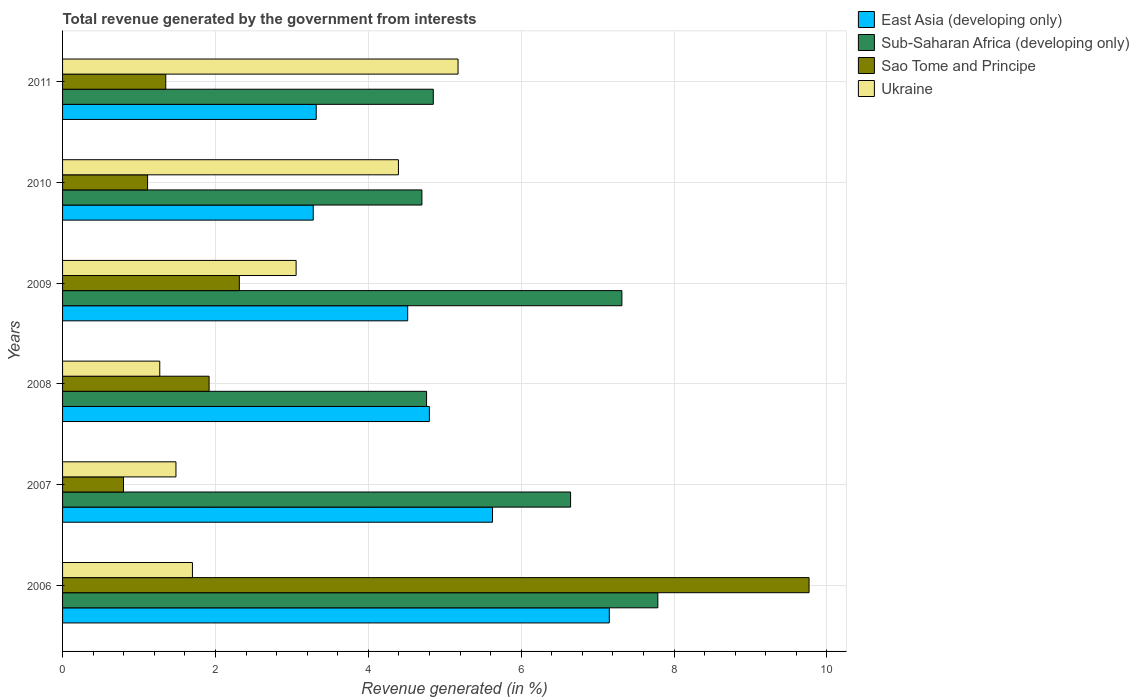How many groups of bars are there?
Provide a succinct answer. 6. Are the number of bars per tick equal to the number of legend labels?
Your answer should be compact. Yes. What is the total revenue generated in Sao Tome and Principe in 2006?
Offer a terse response. 9.77. Across all years, what is the maximum total revenue generated in Sub-Saharan Africa (developing only)?
Ensure brevity in your answer.  7.79. Across all years, what is the minimum total revenue generated in Sub-Saharan Africa (developing only)?
Ensure brevity in your answer.  4.7. What is the total total revenue generated in East Asia (developing only) in the graph?
Provide a short and direct response. 28.69. What is the difference between the total revenue generated in Sub-Saharan Africa (developing only) in 2007 and that in 2010?
Offer a very short reply. 1.95. What is the difference between the total revenue generated in Ukraine in 2009 and the total revenue generated in Sub-Saharan Africa (developing only) in 2007?
Provide a succinct answer. -3.59. What is the average total revenue generated in East Asia (developing only) per year?
Your answer should be compact. 4.78. In the year 2009, what is the difference between the total revenue generated in Ukraine and total revenue generated in East Asia (developing only)?
Offer a terse response. -1.46. What is the ratio of the total revenue generated in Sub-Saharan Africa (developing only) in 2006 to that in 2008?
Your answer should be compact. 1.64. Is the total revenue generated in East Asia (developing only) in 2008 less than that in 2009?
Offer a very short reply. No. Is the difference between the total revenue generated in Ukraine in 2007 and 2011 greater than the difference between the total revenue generated in East Asia (developing only) in 2007 and 2011?
Keep it short and to the point. No. What is the difference between the highest and the second highest total revenue generated in Sub-Saharan Africa (developing only)?
Your answer should be very brief. 0.47. What is the difference between the highest and the lowest total revenue generated in Sub-Saharan Africa (developing only)?
Offer a terse response. 3.09. Is it the case that in every year, the sum of the total revenue generated in Sub-Saharan Africa (developing only) and total revenue generated in East Asia (developing only) is greater than the sum of total revenue generated in Ukraine and total revenue generated in Sao Tome and Principe?
Ensure brevity in your answer.  No. What does the 2nd bar from the top in 2007 represents?
Keep it short and to the point. Sao Tome and Principe. What does the 2nd bar from the bottom in 2007 represents?
Your answer should be compact. Sub-Saharan Africa (developing only). How many bars are there?
Your answer should be very brief. 24. What is the difference between two consecutive major ticks on the X-axis?
Provide a short and direct response. 2. Are the values on the major ticks of X-axis written in scientific E-notation?
Offer a terse response. No. Does the graph contain grids?
Offer a very short reply. Yes. Where does the legend appear in the graph?
Ensure brevity in your answer.  Top right. What is the title of the graph?
Give a very brief answer. Total revenue generated by the government from interests. Does "Zambia" appear as one of the legend labels in the graph?
Offer a terse response. No. What is the label or title of the X-axis?
Your response must be concise. Revenue generated (in %). What is the Revenue generated (in %) in East Asia (developing only) in 2006?
Your response must be concise. 7.15. What is the Revenue generated (in %) in Sub-Saharan Africa (developing only) in 2006?
Make the answer very short. 7.79. What is the Revenue generated (in %) in Sao Tome and Principe in 2006?
Provide a succinct answer. 9.77. What is the Revenue generated (in %) of Ukraine in 2006?
Give a very brief answer. 1.7. What is the Revenue generated (in %) in East Asia (developing only) in 2007?
Give a very brief answer. 5.63. What is the Revenue generated (in %) in Sub-Saharan Africa (developing only) in 2007?
Ensure brevity in your answer.  6.65. What is the Revenue generated (in %) in Sao Tome and Principe in 2007?
Give a very brief answer. 0.8. What is the Revenue generated (in %) in Ukraine in 2007?
Offer a terse response. 1.48. What is the Revenue generated (in %) in East Asia (developing only) in 2008?
Your answer should be very brief. 4.8. What is the Revenue generated (in %) of Sub-Saharan Africa (developing only) in 2008?
Offer a terse response. 4.76. What is the Revenue generated (in %) in Sao Tome and Principe in 2008?
Keep it short and to the point. 1.92. What is the Revenue generated (in %) of Ukraine in 2008?
Ensure brevity in your answer.  1.27. What is the Revenue generated (in %) in East Asia (developing only) in 2009?
Give a very brief answer. 4.52. What is the Revenue generated (in %) of Sub-Saharan Africa (developing only) in 2009?
Offer a very short reply. 7.32. What is the Revenue generated (in %) in Sao Tome and Principe in 2009?
Your answer should be compact. 2.31. What is the Revenue generated (in %) in Ukraine in 2009?
Make the answer very short. 3.06. What is the Revenue generated (in %) of East Asia (developing only) in 2010?
Offer a terse response. 3.28. What is the Revenue generated (in %) of Sub-Saharan Africa (developing only) in 2010?
Provide a short and direct response. 4.7. What is the Revenue generated (in %) of Sao Tome and Principe in 2010?
Provide a short and direct response. 1.11. What is the Revenue generated (in %) of Ukraine in 2010?
Offer a terse response. 4.39. What is the Revenue generated (in %) in East Asia (developing only) in 2011?
Ensure brevity in your answer.  3.32. What is the Revenue generated (in %) of Sub-Saharan Africa (developing only) in 2011?
Your answer should be compact. 4.85. What is the Revenue generated (in %) of Sao Tome and Principe in 2011?
Your answer should be compact. 1.35. What is the Revenue generated (in %) in Ukraine in 2011?
Offer a very short reply. 5.17. Across all years, what is the maximum Revenue generated (in %) in East Asia (developing only)?
Provide a short and direct response. 7.15. Across all years, what is the maximum Revenue generated (in %) of Sub-Saharan Africa (developing only)?
Your answer should be compact. 7.79. Across all years, what is the maximum Revenue generated (in %) in Sao Tome and Principe?
Make the answer very short. 9.77. Across all years, what is the maximum Revenue generated (in %) in Ukraine?
Your answer should be compact. 5.17. Across all years, what is the minimum Revenue generated (in %) in East Asia (developing only)?
Provide a succinct answer. 3.28. Across all years, what is the minimum Revenue generated (in %) of Sub-Saharan Africa (developing only)?
Provide a short and direct response. 4.7. Across all years, what is the minimum Revenue generated (in %) of Sao Tome and Principe?
Ensure brevity in your answer.  0.8. Across all years, what is the minimum Revenue generated (in %) in Ukraine?
Offer a very short reply. 1.27. What is the total Revenue generated (in %) in East Asia (developing only) in the graph?
Ensure brevity in your answer.  28.69. What is the total Revenue generated (in %) of Sub-Saharan Africa (developing only) in the graph?
Provide a short and direct response. 36.07. What is the total Revenue generated (in %) in Sao Tome and Principe in the graph?
Offer a terse response. 17.26. What is the total Revenue generated (in %) of Ukraine in the graph?
Keep it short and to the point. 17.08. What is the difference between the Revenue generated (in %) in East Asia (developing only) in 2006 and that in 2007?
Offer a very short reply. 1.53. What is the difference between the Revenue generated (in %) in Sub-Saharan Africa (developing only) in 2006 and that in 2007?
Your response must be concise. 1.14. What is the difference between the Revenue generated (in %) in Sao Tome and Principe in 2006 and that in 2007?
Provide a short and direct response. 8.97. What is the difference between the Revenue generated (in %) of Ukraine in 2006 and that in 2007?
Your answer should be very brief. 0.22. What is the difference between the Revenue generated (in %) in East Asia (developing only) in 2006 and that in 2008?
Ensure brevity in your answer.  2.35. What is the difference between the Revenue generated (in %) in Sub-Saharan Africa (developing only) in 2006 and that in 2008?
Give a very brief answer. 3.03. What is the difference between the Revenue generated (in %) of Sao Tome and Principe in 2006 and that in 2008?
Keep it short and to the point. 7.85. What is the difference between the Revenue generated (in %) of Ukraine in 2006 and that in 2008?
Your answer should be very brief. 0.43. What is the difference between the Revenue generated (in %) of East Asia (developing only) in 2006 and that in 2009?
Your answer should be very brief. 2.64. What is the difference between the Revenue generated (in %) in Sub-Saharan Africa (developing only) in 2006 and that in 2009?
Your answer should be compact. 0.47. What is the difference between the Revenue generated (in %) in Sao Tome and Principe in 2006 and that in 2009?
Your response must be concise. 7.45. What is the difference between the Revenue generated (in %) of Ukraine in 2006 and that in 2009?
Give a very brief answer. -1.36. What is the difference between the Revenue generated (in %) of East Asia (developing only) in 2006 and that in 2010?
Your answer should be very brief. 3.87. What is the difference between the Revenue generated (in %) in Sub-Saharan Africa (developing only) in 2006 and that in 2010?
Your answer should be very brief. 3.09. What is the difference between the Revenue generated (in %) in Sao Tome and Principe in 2006 and that in 2010?
Provide a short and direct response. 8.65. What is the difference between the Revenue generated (in %) in Ukraine in 2006 and that in 2010?
Keep it short and to the point. -2.7. What is the difference between the Revenue generated (in %) of East Asia (developing only) in 2006 and that in 2011?
Provide a short and direct response. 3.83. What is the difference between the Revenue generated (in %) of Sub-Saharan Africa (developing only) in 2006 and that in 2011?
Give a very brief answer. 2.94. What is the difference between the Revenue generated (in %) in Sao Tome and Principe in 2006 and that in 2011?
Ensure brevity in your answer.  8.42. What is the difference between the Revenue generated (in %) of Ukraine in 2006 and that in 2011?
Make the answer very short. -3.48. What is the difference between the Revenue generated (in %) in East Asia (developing only) in 2007 and that in 2008?
Give a very brief answer. 0.83. What is the difference between the Revenue generated (in %) in Sub-Saharan Africa (developing only) in 2007 and that in 2008?
Ensure brevity in your answer.  1.88. What is the difference between the Revenue generated (in %) in Sao Tome and Principe in 2007 and that in 2008?
Keep it short and to the point. -1.12. What is the difference between the Revenue generated (in %) of Ukraine in 2007 and that in 2008?
Your response must be concise. 0.21. What is the difference between the Revenue generated (in %) of East Asia (developing only) in 2007 and that in 2009?
Give a very brief answer. 1.11. What is the difference between the Revenue generated (in %) of Sub-Saharan Africa (developing only) in 2007 and that in 2009?
Keep it short and to the point. -0.67. What is the difference between the Revenue generated (in %) of Sao Tome and Principe in 2007 and that in 2009?
Provide a succinct answer. -1.52. What is the difference between the Revenue generated (in %) in Ukraine in 2007 and that in 2009?
Your answer should be compact. -1.57. What is the difference between the Revenue generated (in %) of East Asia (developing only) in 2007 and that in 2010?
Make the answer very short. 2.35. What is the difference between the Revenue generated (in %) in Sub-Saharan Africa (developing only) in 2007 and that in 2010?
Offer a terse response. 1.95. What is the difference between the Revenue generated (in %) in Sao Tome and Principe in 2007 and that in 2010?
Offer a very short reply. -0.31. What is the difference between the Revenue generated (in %) of Ukraine in 2007 and that in 2010?
Give a very brief answer. -2.91. What is the difference between the Revenue generated (in %) of East Asia (developing only) in 2007 and that in 2011?
Give a very brief answer. 2.31. What is the difference between the Revenue generated (in %) of Sub-Saharan Africa (developing only) in 2007 and that in 2011?
Keep it short and to the point. 1.8. What is the difference between the Revenue generated (in %) of Sao Tome and Principe in 2007 and that in 2011?
Offer a very short reply. -0.55. What is the difference between the Revenue generated (in %) in Ukraine in 2007 and that in 2011?
Keep it short and to the point. -3.69. What is the difference between the Revenue generated (in %) of East Asia (developing only) in 2008 and that in 2009?
Provide a short and direct response. 0.28. What is the difference between the Revenue generated (in %) of Sub-Saharan Africa (developing only) in 2008 and that in 2009?
Give a very brief answer. -2.56. What is the difference between the Revenue generated (in %) of Sao Tome and Principe in 2008 and that in 2009?
Make the answer very short. -0.4. What is the difference between the Revenue generated (in %) of Ukraine in 2008 and that in 2009?
Your answer should be compact. -1.78. What is the difference between the Revenue generated (in %) in East Asia (developing only) in 2008 and that in 2010?
Ensure brevity in your answer.  1.52. What is the difference between the Revenue generated (in %) in Sub-Saharan Africa (developing only) in 2008 and that in 2010?
Make the answer very short. 0.06. What is the difference between the Revenue generated (in %) of Sao Tome and Principe in 2008 and that in 2010?
Your answer should be compact. 0.8. What is the difference between the Revenue generated (in %) in Ukraine in 2008 and that in 2010?
Your response must be concise. -3.12. What is the difference between the Revenue generated (in %) of East Asia (developing only) in 2008 and that in 2011?
Your answer should be very brief. 1.48. What is the difference between the Revenue generated (in %) of Sub-Saharan Africa (developing only) in 2008 and that in 2011?
Offer a very short reply. -0.09. What is the difference between the Revenue generated (in %) in Sao Tome and Principe in 2008 and that in 2011?
Ensure brevity in your answer.  0.57. What is the difference between the Revenue generated (in %) in Ukraine in 2008 and that in 2011?
Your response must be concise. -3.9. What is the difference between the Revenue generated (in %) of East Asia (developing only) in 2009 and that in 2010?
Provide a succinct answer. 1.24. What is the difference between the Revenue generated (in %) of Sub-Saharan Africa (developing only) in 2009 and that in 2010?
Offer a terse response. 2.62. What is the difference between the Revenue generated (in %) of Sao Tome and Principe in 2009 and that in 2010?
Provide a succinct answer. 1.2. What is the difference between the Revenue generated (in %) in Ukraine in 2009 and that in 2010?
Your response must be concise. -1.34. What is the difference between the Revenue generated (in %) of East Asia (developing only) in 2009 and that in 2011?
Offer a terse response. 1.2. What is the difference between the Revenue generated (in %) of Sub-Saharan Africa (developing only) in 2009 and that in 2011?
Ensure brevity in your answer.  2.47. What is the difference between the Revenue generated (in %) of Sao Tome and Principe in 2009 and that in 2011?
Give a very brief answer. 0.96. What is the difference between the Revenue generated (in %) of Ukraine in 2009 and that in 2011?
Offer a very short reply. -2.12. What is the difference between the Revenue generated (in %) in East Asia (developing only) in 2010 and that in 2011?
Give a very brief answer. -0.04. What is the difference between the Revenue generated (in %) in Sub-Saharan Africa (developing only) in 2010 and that in 2011?
Keep it short and to the point. -0.15. What is the difference between the Revenue generated (in %) in Sao Tome and Principe in 2010 and that in 2011?
Keep it short and to the point. -0.24. What is the difference between the Revenue generated (in %) of Ukraine in 2010 and that in 2011?
Ensure brevity in your answer.  -0.78. What is the difference between the Revenue generated (in %) in East Asia (developing only) in 2006 and the Revenue generated (in %) in Sub-Saharan Africa (developing only) in 2007?
Keep it short and to the point. 0.51. What is the difference between the Revenue generated (in %) of East Asia (developing only) in 2006 and the Revenue generated (in %) of Sao Tome and Principe in 2007?
Offer a terse response. 6.36. What is the difference between the Revenue generated (in %) of East Asia (developing only) in 2006 and the Revenue generated (in %) of Ukraine in 2007?
Your answer should be very brief. 5.67. What is the difference between the Revenue generated (in %) in Sub-Saharan Africa (developing only) in 2006 and the Revenue generated (in %) in Sao Tome and Principe in 2007?
Give a very brief answer. 6.99. What is the difference between the Revenue generated (in %) of Sub-Saharan Africa (developing only) in 2006 and the Revenue generated (in %) of Ukraine in 2007?
Make the answer very short. 6.3. What is the difference between the Revenue generated (in %) in Sao Tome and Principe in 2006 and the Revenue generated (in %) in Ukraine in 2007?
Ensure brevity in your answer.  8.28. What is the difference between the Revenue generated (in %) of East Asia (developing only) in 2006 and the Revenue generated (in %) of Sub-Saharan Africa (developing only) in 2008?
Ensure brevity in your answer.  2.39. What is the difference between the Revenue generated (in %) in East Asia (developing only) in 2006 and the Revenue generated (in %) in Sao Tome and Principe in 2008?
Provide a short and direct response. 5.24. What is the difference between the Revenue generated (in %) of East Asia (developing only) in 2006 and the Revenue generated (in %) of Ukraine in 2008?
Your answer should be very brief. 5.88. What is the difference between the Revenue generated (in %) of Sub-Saharan Africa (developing only) in 2006 and the Revenue generated (in %) of Sao Tome and Principe in 2008?
Your answer should be very brief. 5.87. What is the difference between the Revenue generated (in %) in Sub-Saharan Africa (developing only) in 2006 and the Revenue generated (in %) in Ukraine in 2008?
Make the answer very short. 6.52. What is the difference between the Revenue generated (in %) in Sao Tome and Principe in 2006 and the Revenue generated (in %) in Ukraine in 2008?
Your answer should be compact. 8.5. What is the difference between the Revenue generated (in %) of East Asia (developing only) in 2006 and the Revenue generated (in %) of Sub-Saharan Africa (developing only) in 2009?
Your response must be concise. -0.16. What is the difference between the Revenue generated (in %) of East Asia (developing only) in 2006 and the Revenue generated (in %) of Sao Tome and Principe in 2009?
Give a very brief answer. 4.84. What is the difference between the Revenue generated (in %) of East Asia (developing only) in 2006 and the Revenue generated (in %) of Ukraine in 2009?
Make the answer very short. 4.1. What is the difference between the Revenue generated (in %) of Sub-Saharan Africa (developing only) in 2006 and the Revenue generated (in %) of Sao Tome and Principe in 2009?
Give a very brief answer. 5.48. What is the difference between the Revenue generated (in %) in Sub-Saharan Africa (developing only) in 2006 and the Revenue generated (in %) in Ukraine in 2009?
Give a very brief answer. 4.73. What is the difference between the Revenue generated (in %) of Sao Tome and Principe in 2006 and the Revenue generated (in %) of Ukraine in 2009?
Offer a terse response. 6.71. What is the difference between the Revenue generated (in %) in East Asia (developing only) in 2006 and the Revenue generated (in %) in Sub-Saharan Africa (developing only) in 2010?
Offer a terse response. 2.45. What is the difference between the Revenue generated (in %) in East Asia (developing only) in 2006 and the Revenue generated (in %) in Sao Tome and Principe in 2010?
Your answer should be compact. 6.04. What is the difference between the Revenue generated (in %) of East Asia (developing only) in 2006 and the Revenue generated (in %) of Ukraine in 2010?
Your response must be concise. 2.76. What is the difference between the Revenue generated (in %) of Sub-Saharan Africa (developing only) in 2006 and the Revenue generated (in %) of Sao Tome and Principe in 2010?
Provide a short and direct response. 6.68. What is the difference between the Revenue generated (in %) in Sub-Saharan Africa (developing only) in 2006 and the Revenue generated (in %) in Ukraine in 2010?
Provide a succinct answer. 3.39. What is the difference between the Revenue generated (in %) of Sao Tome and Principe in 2006 and the Revenue generated (in %) of Ukraine in 2010?
Keep it short and to the point. 5.37. What is the difference between the Revenue generated (in %) in East Asia (developing only) in 2006 and the Revenue generated (in %) in Sub-Saharan Africa (developing only) in 2011?
Keep it short and to the point. 2.3. What is the difference between the Revenue generated (in %) of East Asia (developing only) in 2006 and the Revenue generated (in %) of Sao Tome and Principe in 2011?
Provide a short and direct response. 5.8. What is the difference between the Revenue generated (in %) of East Asia (developing only) in 2006 and the Revenue generated (in %) of Ukraine in 2011?
Offer a terse response. 1.98. What is the difference between the Revenue generated (in %) of Sub-Saharan Africa (developing only) in 2006 and the Revenue generated (in %) of Sao Tome and Principe in 2011?
Your answer should be compact. 6.44. What is the difference between the Revenue generated (in %) of Sub-Saharan Africa (developing only) in 2006 and the Revenue generated (in %) of Ukraine in 2011?
Offer a terse response. 2.61. What is the difference between the Revenue generated (in %) in Sao Tome and Principe in 2006 and the Revenue generated (in %) in Ukraine in 2011?
Your answer should be very brief. 4.59. What is the difference between the Revenue generated (in %) in East Asia (developing only) in 2007 and the Revenue generated (in %) in Sub-Saharan Africa (developing only) in 2008?
Your answer should be very brief. 0.86. What is the difference between the Revenue generated (in %) of East Asia (developing only) in 2007 and the Revenue generated (in %) of Sao Tome and Principe in 2008?
Offer a very short reply. 3.71. What is the difference between the Revenue generated (in %) in East Asia (developing only) in 2007 and the Revenue generated (in %) in Ukraine in 2008?
Make the answer very short. 4.35. What is the difference between the Revenue generated (in %) in Sub-Saharan Africa (developing only) in 2007 and the Revenue generated (in %) in Sao Tome and Principe in 2008?
Your answer should be very brief. 4.73. What is the difference between the Revenue generated (in %) in Sub-Saharan Africa (developing only) in 2007 and the Revenue generated (in %) in Ukraine in 2008?
Your answer should be very brief. 5.37. What is the difference between the Revenue generated (in %) in Sao Tome and Principe in 2007 and the Revenue generated (in %) in Ukraine in 2008?
Your answer should be compact. -0.47. What is the difference between the Revenue generated (in %) of East Asia (developing only) in 2007 and the Revenue generated (in %) of Sub-Saharan Africa (developing only) in 2009?
Your answer should be compact. -1.69. What is the difference between the Revenue generated (in %) of East Asia (developing only) in 2007 and the Revenue generated (in %) of Sao Tome and Principe in 2009?
Your answer should be very brief. 3.31. What is the difference between the Revenue generated (in %) in East Asia (developing only) in 2007 and the Revenue generated (in %) in Ukraine in 2009?
Provide a succinct answer. 2.57. What is the difference between the Revenue generated (in %) of Sub-Saharan Africa (developing only) in 2007 and the Revenue generated (in %) of Sao Tome and Principe in 2009?
Your answer should be very brief. 4.33. What is the difference between the Revenue generated (in %) of Sub-Saharan Africa (developing only) in 2007 and the Revenue generated (in %) of Ukraine in 2009?
Keep it short and to the point. 3.59. What is the difference between the Revenue generated (in %) in Sao Tome and Principe in 2007 and the Revenue generated (in %) in Ukraine in 2009?
Provide a succinct answer. -2.26. What is the difference between the Revenue generated (in %) of East Asia (developing only) in 2007 and the Revenue generated (in %) of Sub-Saharan Africa (developing only) in 2010?
Provide a succinct answer. 0.92. What is the difference between the Revenue generated (in %) in East Asia (developing only) in 2007 and the Revenue generated (in %) in Sao Tome and Principe in 2010?
Provide a succinct answer. 4.51. What is the difference between the Revenue generated (in %) of East Asia (developing only) in 2007 and the Revenue generated (in %) of Ukraine in 2010?
Offer a very short reply. 1.23. What is the difference between the Revenue generated (in %) in Sub-Saharan Africa (developing only) in 2007 and the Revenue generated (in %) in Sao Tome and Principe in 2010?
Your answer should be compact. 5.53. What is the difference between the Revenue generated (in %) of Sub-Saharan Africa (developing only) in 2007 and the Revenue generated (in %) of Ukraine in 2010?
Provide a short and direct response. 2.25. What is the difference between the Revenue generated (in %) in Sao Tome and Principe in 2007 and the Revenue generated (in %) in Ukraine in 2010?
Keep it short and to the point. -3.6. What is the difference between the Revenue generated (in %) in East Asia (developing only) in 2007 and the Revenue generated (in %) in Sub-Saharan Africa (developing only) in 2011?
Ensure brevity in your answer.  0.77. What is the difference between the Revenue generated (in %) in East Asia (developing only) in 2007 and the Revenue generated (in %) in Sao Tome and Principe in 2011?
Keep it short and to the point. 4.28. What is the difference between the Revenue generated (in %) of East Asia (developing only) in 2007 and the Revenue generated (in %) of Ukraine in 2011?
Offer a terse response. 0.45. What is the difference between the Revenue generated (in %) of Sub-Saharan Africa (developing only) in 2007 and the Revenue generated (in %) of Sao Tome and Principe in 2011?
Make the answer very short. 5.3. What is the difference between the Revenue generated (in %) in Sub-Saharan Africa (developing only) in 2007 and the Revenue generated (in %) in Ukraine in 2011?
Your answer should be very brief. 1.47. What is the difference between the Revenue generated (in %) in Sao Tome and Principe in 2007 and the Revenue generated (in %) in Ukraine in 2011?
Keep it short and to the point. -4.38. What is the difference between the Revenue generated (in %) in East Asia (developing only) in 2008 and the Revenue generated (in %) in Sub-Saharan Africa (developing only) in 2009?
Your answer should be compact. -2.52. What is the difference between the Revenue generated (in %) of East Asia (developing only) in 2008 and the Revenue generated (in %) of Sao Tome and Principe in 2009?
Keep it short and to the point. 2.49. What is the difference between the Revenue generated (in %) in East Asia (developing only) in 2008 and the Revenue generated (in %) in Ukraine in 2009?
Make the answer very short. 1.74. What is the difference between the Revenue generated (in %) in Sub-Saharan Africa (developing only) in 2008 and the Revenue generated (in %) in Sao Tome and Principe in 2009?
Give a very brief answer. 2.45. What is the difference between the Revenue generated (in %) of Sub-Saharan Africa (developing only) in 2008 and the Revenue generated (in %) of Ukraine in 2009?
Keep it short and to the point. 1.71. What is the difference between the Revenue generated (in %) in Sao Tome and Principe in 2008 and the Revenue generated (in %) in Ukraine in 2009?
Your answer should be very brief. -1.14. What is the difference between the Revenue generated (in %) in East Asia (developing only) in 2008 and the Revenue generated (in %) in Sub-Saharan Africa (developing only) in 2010?
Make the answer very short. 0.1. What is the difference between the Revenue generated (in %) of East Asia (developing only) in 2008 and the Revenue generated (in %) of Sao Tome and Principe in 2010?
Your response must be concise. 3.69. What is the difference between the Revenue generated (in %) of East Asia (developing only) in 2008 and the Revenue generated (in %) of Ukraine in 2010?
Give a very brief answer. 0.4. What is the difference between the Revenue generated (in %) in Sub-Saharan Africa (developing only) in 2008 and the Revenue generated (in %) in Sao Tome and Principe in 2010?
Your answer should be very brief. 3.65. What is the difference between the Revenue generated (in %) of Sub-Saharan Africa (developing only) in 2008 and the Revenue generated (in %) of Ukraine in 2010?
Give a very brief answer. 0.37. What is the difference between the Revenue generated (in %) of Sao Tome and Principe in 2008 and the Revenue generated (in %) of Ukraine in 2010?
Ensure brevity in your answer.  -2.48. What is the difference between the Revenue generated (in %) of East Asia (developing only) in 2008 and the Revenue generated (in %) of Sub-Saharan Africa (developing only) in 2011?
Make the answer very short. -0.05. What is the difference between the Revenue generated (in %) in East Asia (developing only) in 2008 and the Revenue generated (in %) in Sao Tome and Principe in 2011?
Offer a very short reply. 3.45. What is the difference between the Revenue generated (in %) of East Asia (developing only) in 2008 and the Revenue generated (in %) of Ukraine in 2011?
Your response must be concise. -0.38. What is the difference between the Revenue generated (in %) of Sub-Saharan Africa (developing only) in 2008 and the Revenue generated (in %) of Sao Tome and Principe in 2011?
Provide a succinct answer. 3.41. What is the difference between the Revenue generated (in %) in Sub-Saharan Africa (developing only) in 2008 and the Revenue generated (in %) in Ukraine in 2011?
Offer a very short reply. -0.41. What is the difference between the Revenue generated (in %) in Sao Tome and Principe in 2008 and the Revenue generated (in %) in Ukraine in 2011?
Your answer should be compact. -3.26. What is the difference between the Revenue generated (in %) in East Asia (developing only) in 2009 and the Revenue generated (in %) in Sub-Saharan Africa (developing only) in 2010?
Ensure brevity in your answer.  -0.19. What is the difference between the Revenue generated (in %) in East Asia (developing only) in 2009 and the Revenue generated (in %) in Sao Tome and Principe in 2010?
Offer a terse response. 3.4. What is the difference between the Revenue generated (in %) of East Asia (developing only) in 2009 and the Revenue generated (in %) of Ukraine in 2010?
Provide a short and direct response. 0.12. What is the difference between the Revenue generated (in %) of Sub-Saharan Africa (developing only) in 2009 and the Revenue generated (in %) of Sao Tome and Principe in 2010?
Your answer should be compact. 6.21. What is the difference between the Revenue generated (in %) of Sub-Saharan Africa (developing only) in 2009 and the Revenue generated (in %) of Ukraine in 2010?
Offer a terse response. 2.92. What is the difference between the Revenue generated (in %) of Sao Tome and Principe in 2009 and the Revenue generated (in %) of Ukraine in 2010?
Offer a very short reply. -2.08. What is the difference between the Revenue generated (in %) of East Asia (developing only) in 2009 and the Revenue generated (in %) of Sub-Saharan Africa (developing only) in 2011?
Make the answer very short. -0.34. What is the difference between the Revenue generated (in %) in East Asia (developing only) in 2009 and the Revenue generated (in %) in Sao Tome and Principe in 2011?
Make the answer very short. 3.17. What is the difference between the Revenue generated (in %) of East Asia (developing only) in 2009 and the Revenue generated (in %) of Ukraine in 2011?
Offer a terse response. -0.66. What is the difference between the Revenue generated (in %) in Sub-Saharan Africa (developing only) in 2009 and the Revenue generated (in %) in Sao Tome and Principe in 2011?
Your answer should be very brief. 5.97. What is the difference between the Revenue generated (in %) in Sub-Saharan Africa (developing only) in 2009 and the Revenue generated (in %) in Ukraine in 2011?
Provide a short and direct response. 2.14. What is the difference between the Revenue generated (in %) of Sao Tome and Principe in 2009 and the Revenue generated (in %) of Ukraine in 2011?
Give a very brief answer. -2.86. What is the difference between the Revenue generated (in %) of East Asia (developing only) in 2010 and the Revenue generated (in %) of Sub-Saharan Africa (developing only) in 2011?
Keep it short and to the point. -1.57. What is the difference between the Revenue generated (in %) in East Asia (developing only) in 2010 and the Revenue generated (in %) in Sao Tome and Principe in 2011?
Keep it short and to the point. 1.93. What is the difference between the Revenue generated (in %) in East Asia (developing only) in 2010 and the Revenue generated (in %) in Ukraine in 2011?
Give a very brief answer. -1.89. What is the difference between the Revenue generated (in %) of Sub-Saharan Africa (developing only) in 2010 and the Revenue generated (in %) of Sao Tome and Principe in 2011?
Make the answer very short. 3.35. What is the difference between the Revenue generated (in %) of Sub-Saharan Africa (developing only) in 2010 and the Revenue generated (in %) of Ukraine in 2011?
Give a very brief answer. -0.47. What is the difference between the Revenue generated (in %) in Sao Tome and Principe in 2010 and the Revenue generated (in %) in Ukraine in 2011?
Your response must be concise. -4.06. What is the average Revenue generated (in %) of East Asia (developing only) per year?
Provide a short and direct response. 4.78. What is the average Revenue generated (in %) in Sub-Saharan Africa (developing only) per year?
Provide a succinct answer. 6.01. What is the average Revenue generated (in %) in Sao Tome and Principe per year?
Offer a terse response. 2.88. What is the average Revenue generated (in %) of Ukraine per year?
Ensure brevity in your answer.  2.85. In the year 2006, what is the difference between the Revenue generated (in %) in East Asia (developing only) and Revenue generated (in %) in Sub-Saharan Africa (developing only)?
Your response must be concise. -0.64. In the year 2006, what is the difference between the Revenue generated (in %) in East Asia (developing only) and Revenue generated (in %) in Sao Tome and Principe?
Your answer should be very brief. -2.61. In the year 2006, what is the difference between the Revenue generated (in %) in East Asia (developing only) and Revenue generated (in %) in Ukraine?
Offer a very short reply. 5.45. In the year 2006, what is the difference between the Revenue generated (in %) in Sub-Saharan Africa (developing only) and Revenue generated (in %) in Sao Tome and Principe?
Ensure brevity in your answer.  -1.98. In the year 2006, what is the difference between the Revenue generated (in %) of Sub-Saharan Africa (developing only) and Revenue generated (in %) of Ukraine?
Give a very brief answer. 6.09. In the year 2006, what is the difference between the Revenue generated (in %) in Sao Tome and Principe and Revenue generated (in %) in Ukraine?
Provide a succinct answer. 8.07. In the year 2007, what is the difference between the Revenue generated (in %) of East Asia (developing only) and Revenue generated (in %) of Sub-Saharan Africa (developing only)?
Provide a short and direct response. -1.02. In the year 2007, what is the difference between the Revenue generated (in %) in East Asia (developing only) and Revenue generated (in %) in Sao Tome and Principe?
Provide a succinct answer. 4.83. In the year 2007, what is the difference between the Revenue generated (in %) in East Asia (developing only) and Revenue generated (in %) in Ukraine?
Ensure brevity in your answer.  4.14. In the year 2007, what is the difference between the Revenue generated (in %) in Sub-Saharan Africa (developing only) and Revenue generated (in %) in Sao Tome and Principe?
Give a very brief answer. 5.85. In the year 2007, what is the difference between the Revenue generated (in %) in Sub-Saharan Africa (developing only) and Revenue generated (in %) in Ukraine?
Make the answer very short. 5.16. In the year 2007, what is the difference between the Revenue generated (in %) in Sao Tome and Principe and Revenue generated (in %) in Ukraine?
Offer a very short reply. -0.69. In the year 2008, what is the difference between the Revenue generated (in %) in East Asia (developing only) and Revenue generated (in %) in Sub-Saharan Africa (developing only)?
Offer a very short reply. 0.04. In the year 2008, what is the difference between the Revenue generated (in %) of East Asia (developing only) and Revenue generated (in %) of Sao Tome and Principe?
Ensure brevity in your answer.  2.88. In the year 2008, what is the difference between the Revenue generated (in %) in East Asia (developing only) and Revenue generated (in %) in Ukraine?
Your answer should be compact. 3.53. In the year 2008, what is the difference between the Revenue generated (in %) of Sub-Saharan Africa (developing only) and Revenue generated (in %) of Sao Tome and Principe?
Provide a succinct answer. 2.85. In the year 2008, what is the difference between the Revenue generated (in %) of Sub-Saharan Africa (developing only) and Revenue generated (in %) of Ukraine?
Offer a terse response. 3.49. In the year 2008, what is the difference between the Revenue generated (in %) in Sao Tome and Principe and Revenue generated (in %) in Ukraine?
Your answer should be compact. 0.65. In the year 2009, what is the difference between the Revenue generated (in %) of East Asia (developing only) and Revenue generated (in %) of Sub-Saharan Africa (developing only)?
Offer a terse response. -2.8. In the year 2009, what is the difference between the Revenue generated (in %) in East Asia (developing only) and Revenue generated (in %) in Sao Tome and Principe?
Offer a very short reply. 2.2. In the year 2009, what is the difference between the Revenue generated (in %) of East Asia (developing only) and Revenue generated (in %) of Ukraine?
Your response must be concise. 1.46. In the year 2009, what is the difference between the Revenue generated (in %) in Sub-Saharan Africa (developing only) and Revenue generated (in %) in Sao Tome and Principe?
Your response must be concise. 5.01. In the year 2009, what is the difference between the Revenue generated (in %) of Sub-Saharan Africa (developing only) and Revenue generated (in %) of Ukraine?
Give a very brief answer. 4.26. In the year 2009, what is the difference between the Revenue generated (in %) in Sao Tome and Principe and Revenue generated (in %) in Ukraine?
Your answer should be very brief. -0.74. In the year 2010, what is the difference between the Revenue generated (in %) of East Asia (developing only) and Revenue generated (in %) of Sub-Saharan Africa (developing only)?
Keep it short and to the point. -1.42. In the year 2010, what is the difference between the Revenue generated (in %) of East Asia (developing only) and Revenue generated (in %) of Sao Tome and Principe?
Ensure brevity in your answer.  2.17. In the year 2010, what is the difference between the Revenue generated (in %) of East Asia (developing only) and Revenue generated (in %) of Ukraine?
Offer a terse response. -1.11. In the year 2010, what is the difference between the Revenue generated (in %) in Sub-Saharan Africa (developing only) and Revenue generated (in %) in Sao Tome and Principe?
Offer a terse response. 3.59. In the year 2010, what is the difference between the Revenue generated (in %) of Sub-Saharan Africa (developing only) and Revenue generated (in %) of Ukraine?
Provide a short and direct response. 0.31. In the year 2010, what is the difference between the Revenue generated (in %) in Sao Tome and Principe and Revenue generated (in %) in Ukraine?
Make the answer very short. -3.28. In the year 2011, what is the difference between the Revenue generated (in %) in East Asia (developing only) and Revenue generated (in %) in Sub-Saharan Africa (developing only)?
Your answer should be compact. -1.53. In the year 2011, what is the difference between the Revenue generated (in %) in East Asia (developing only) and Revenue generated (in %) in Sao Tome and Principe?
Give a very brief answer. 1.97. In the year 2011, what is the difference between the Revenue generated (in %) of East Asia (developing only) and Revenue generated (in %) of Ukraine?
Offer a very short reply. -1.86. In the year 2011, what is the difference between the Revenue generated (in %) in Sub-Saharan Africa (developing only) and Revenue generated (in %) in Sao Tome and Principe?
Your answer should be compact. 3.5. In the year 2011, what is the difference between the Revenue generated (in %) in Sub-Saharan Africa (developing only) and Revenue generated (in %) in Ukraine?
Make the answer very short. -0.32. In the year 2011, what is the difference between the Revenue generated (in %) of Sao Tome and Principe and Revenue generated (in %) of Ukraine?
Give a very brief answer. -3.82. What is the ratio of the Revenue generated (in %) in East Asia (developing only) in 2006 to that in 2007?
Provide a succinct answer. 1.27. What is the ratio of the Revenue generated (in %) in Sub-Saharan Africa (developing only) in 2006 to that in 2007?
Provide a succinct answer. 1.17. What is the ratio of the Revenue generated (in %) in Sao Tome and Principe in 2006 to that in 2007?
Offer a terse response. 12.25. What is the ratio of the Revenue generated (in %) of Ukraine in 2006 to that in 2007?
Your answer should be very brief. 1.15. What is the ratio of the Revenue generated (in %) in East Asia (developing only) in 2006 to that in 2008?
Your answer should be compact. 1.49. What is the ratio of the Revenue generated (in %) of Sub-Saharan Africa (developing only) in 2006 to that in 2008?
Provide a succinct answer. 1.64. What is the ratio of the Revenue generated (in %) of Sao Tome and Principe in 2006 to that in 2008?
Provide a short and direct response. 5.09. What is the ratio of the Revenue generated (in %) of Ukraine in 2006 to that in 2008?
Give a very brief answer. 1.34. What is the ratio of the Revenue generated (in %) of East Asia (developing only) in 2006 to that in 2009?
Offer a terse response. 1.58. What is the ratio of the Revenue generated (in %) in Sub-Saharan Africa (developing only) in 2006 to that in 2009?
Offer a very short reply. 1.06. What is the ratio of the Revenue generated (in %) in Sao Tome and Principe in 2006 to that in 2009?
Provide a short and direct response. 4.22. What is the ratio of the Revenue generated (in %) in Ukraine in 2006 to that in 2009?
Provide a short and direct response. 0.56. What is the ratio of the Revenue generated (in %) of East Asia (developing only) in 2006 to that in 2010?
Provide a succinct answer. 2.18. What is the ratio of the Revenue generated (in %) of Sub-Saharan Africa (developing only) in 2006 to that in 2010?
Make the answer very short. 1.66. What is the ratio of the Revenue generated (in %) in Sao Tome and Principe in 2006 to that in 2010?
Provide a short and direct response. 8.78. What is the ratio of the Revenue generated (in %) in Ukraine in 2006 to that in 2010?
Provide a succinct answer. 0.39. What is the ratio of the Revenue generated (in %) in East Asia (developing only) in 2006 to that in 2011?
Ensure brevity in your answer.  2.16. What is the ratio of the Revenue generated (in %) of Sub-Saharan Africa (developing only) in 2006 to that in 2011?
Offer a very short reply. 1.61. What is the ratio of the Revenue generated (in %) of Sao Tome and Principe in 2006 to that in 2011?
Provide a short and direct response. 7.23. What is the ratio of the Revenue generated (in %) of Ukraine in 2006 to that in 2011?
Make the answer very short. 0.33. What is the ratio of the Revenue generated (in %) of East Asia (developing only) in 2007 to that in 2008?
Give a very brief answer. 1.17. What is the ratio of the Revenue generated (in %) of Sub-Saharan Africa (developing only) in 2007 to that in 2008?
Your response must be concise. 1.4. What is the ratio of the Revenue generated (in %) of Sao Tome and Principe in 2007 to that in 2008?
Your response must be concise. 0.42. What is the ratio of the Revenue generated (in %) in Ukraine in 2007 to that in 2008?
Keep it short and to the point. 1.17. What is the ratio of the Revenue generated (in %) in East Asia (developing only) in 2007 to that in 2009?
Keep it short and to the point. 1.25. What is the ratio of the Revenue generated (in %) of Sub-Saharan Africa (developing only) in 2007 to that in 2009?
Provide a short and direct response. 0.91. What is the ratio of the Revenue generated (in %) in Sao Tome and Principe in 2007 to that in 2009?
Offer a very short reply. 0.34. What is the ratio of the Revenue generated (in %) in Ukraine in 2007 to that in 2009?
Your response must be concise. 0.49. What is the ratio of the Revenue generated (in %) in East Asia (developing only) in 2007 to that in 2010?
Offer a very short reply. 1.72. What is the ratio of the Revenue generated (in %) in Sub-Saharan Africa (developing only) in 2007 to that in 2010?
Make the answer very short. 1.41. What is the ratio of the Revenue generated (in %) in Sao Tome and Principe in 2007 to that in 2010?
Provide a short and direct response. 0.72. What is the ratio of the Revenue generated (in %) in Ukraine in 2007 to that in 2010?
Your answer should be compact. 0.34. What is the ratio of the Revenue generated (in %) of East Asia (developing only) in 2007 to that in 2011?
Your response must be concise. 1.7. What is the ratio of the Revenue generated (in %) of Sub-Saharan Africa (developing only) in 2007 to that in 2011?
Your answer should be compact. 1.37. What is the ratio of the Revenue generated (in %) of Sao Tome and Principe in 2007 to that in 2011?
Make the answer very short. 0.59. What is the ratio of the Revenue generated (in %) of Ukraine in 2007 to that in 2011?
Your answer should be compact. 0.29. What is the ratio of the Revenue generated (in %) of East Asia (developing only) in 2008 to that in 2009?
Make the answer very short. 1.06. What is the ratio of the Revenue generated (in %) in Sub-Saharan Africa (developing only) in 2008 to that in 2009?
Provide a short and direct response. 0.65. What is the ratio of the Revenue generated (in %) in Sao Tome and Principe in 2008 to that in 2009?
Offer a very short reply. 0.83. What is the ratio of the Revenue generated (in %) of Ukraine in 2008 to that in 2009?
Your answer should be compact. 0.42. What is the ratio of the Revenue generated (in %) of East Asia (developing only) in 2008 to that in 2010?
Your answer should be compact. 1.46. What is the ratio of the Revenue generated (in %) in Sub-Saharan Africa (developing only) in 2008 to that in 2010?
Your answer should be compact. 1.01. What is the ratio of the Revenue generated (in %) of Sao Tome and Principe in 2008 to that in 2010?
Give a very brief answer. 1.72. What is the ratio of the Revenue generated (in %) in Ukraine in 2008 to that in 2010?
Offer a very short reply. 0.29. What is the ratio of the Revenue generated (in %) in East Asia (developing only) in 2008 to that in 2011?
Your answer should be very brief. 1.45. What is the ratio of the Revenue generated (in %) of Sub-Saharan Africa (developing only) in 2008 to that in 2011?
Your answer should be very brief. 0.98. What is the ratio of the Revenue generated (in %) of Sao Tome and Principe in 2008 to that in 2011?
Provide a succinct answer. 1.42. What is the ratio of the Revenue generated (in %) of Ukraine in 2008 to that in 2011?
Offer a terse response. 0.25. What is the ratio of the Revenue generated (in %) of East Asia (developing only) in 2009 to that in 2010?
Provide a short and direct response. 1.38. What is the ratio of the Revenue generated (in %) of Sub-Saharan Africa (developing only) in 2009 to that in 2010?
Provide a succinct answer. 1.56. What is the ratio of the Revenue generated (in %) of Sao Tome and Principe in 2009 to that in 2010?
Offer a very short reply. 2.08. What is the ratio of the Revenue generated (in %) of Ukraine in 2009 to that in 2010?
Ensure brevity in your answer.  0.7. What is the ratio of the Revenue generated (in %) of East Asia (developing only) in 2009 to that in 2011?
Give a very brief answer. 1.36. What is the ratio of the Revenue generated (in %) of Sub-Saharan Africa (developing only) in 2009 to that in 2011?
Offer a very short reply. 1.51. What is the ratio of the Revenue generated (in %) of Sao Tome and Principe in 2009 to that in 2011?
Keep it short and to the point. 1.71. What is the ratio of the Revenue generated (in %) in Ukraine in 2009 to that in 2011?
Offer a terse response. 0.59. What is the ratio of the Revenue generated (in %) in East Asia (developing only) in 2010 to that in 2011?
Provide a succinct answer. 0.99. What is the ratio of the Revenue generated (in %) of Sub-Saharan Africa (developing only) in 2010 to that in 2011?
Your response must be concise. 0.97. What is the ratio of the Revenue generated (in %) of Sao Tome and Principe in 2010 to that in 2011?
Provide a succinct answer. 0.82. What is the ratio of the Revenue generated (in %) of Ukraine in 2010 to that in 2011?
Make the answer very short. 0.85. What is the difference between the highest and the second highest Revenue generated (in %) of East Asia (developing only)?
Ensure brevity in your answer.  1.53. What is the difference between the highest and the second highest Revenue generated (in %) of Sub-Saharan Africa (developing only)?
Make the answer very short. 0.47. What is the difference between the highest and the second highest Revenue generated (in %) in Sao Tome and Principe?
Provide a short and direct response. 7.45. What is the difference between the highest and the second highest Revenue generated (in %) in Ukraine?
Keep it short and to the point. 0.78. What is the difference between the highest and the lowest Revenue generated (in %) in East Asia (developing only)?
Your answer should be compact. 3.87. What is the difference between the highest and the lowest Revenue generated (in %) of Sub-Saharan Africa (developing only)?
Ensure brevity in your answer.  3.09. What is the difference between the highest and the lowest Revenue generated (in %) of Sao Tome and Principe?
Your answer should be very brief. 8.97. What is the difference between the highest and the lowest Revenue generated (in %) of Ukraine?
Offer a terse response. 3.9. 